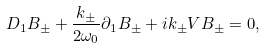<formula> <loc_0><loc_0><loc_500><loc_500>D _ { 1 } B _ { \pm } + \frac { k _ { \pm } } { 2 \omega _ { 0 } } \partial _ { 1 } B _ { \pm } + i k _ { \pm } V B _ { \pm } = 0 ,</formula> 